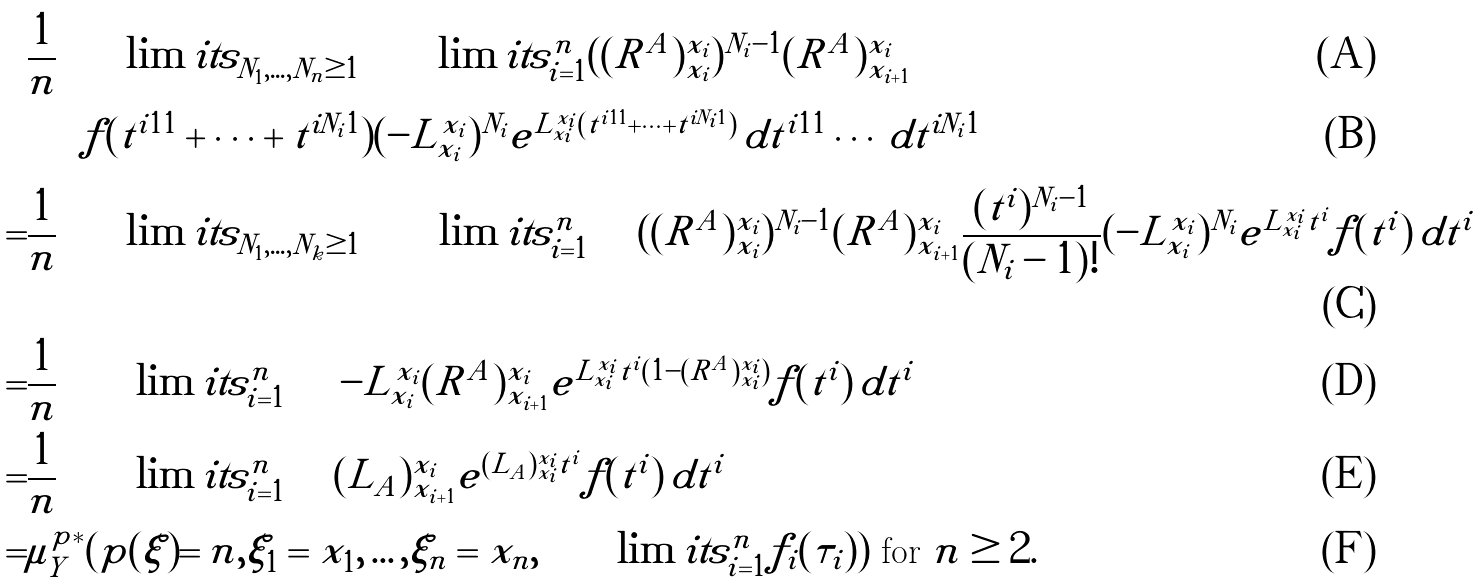<formula> <loc_0><loc_0><loc_500><loc_500>& \frac { 1 } { n } \sum \lim i t s _ { N _ { 1 } , \dots , N _ { n } \geq 1 } \prod \lim i t s _ { i = 1 } ^ { n } ( ( R ^ { A } ) ^ { x _ { i } } _ { x _ { i } } ) ^ { N _ { i } - 1 } ( R ^ { A } ) ^ { x _ { i } } _ { x _ { i + 1 } } \\ & \int f ( t ^ { i 1 1 } + \cdots + t ^ { i N _ { i } 1 } ) ( - L ^ { x _ { i } } _ { x _ { i } } ) ^ { N _ { i } } e ^ { L ^ { x _ { i } } _ { x _ { i } } ( t ^ { i 1 1 } + \cdots + t ^ { i N _ { i } 1 } ) } \, d t ^ { i 1 1 } \cdots \, d t ^ { i N _ { i } 1 } \\ = & \frac { 1 } { n } \sum \lim i t s _ { N _ { 1 } , \dots , N _ { k } \geq 1 } \prod \lim i t s _ { i = 1 } ^ { n } \int ( ( R ^ { A } ) ^ { x _ { i } } _ { x _ { i } } ) ^ { N _ { i } - 1 } ( R ^ { A } ) ^ { x _ { i } } _ { x _ { i + 1 } } \frac { ( t ^ { i } ) ^ { N _ { i } - 1 } } { ( N _ { i } - 1 ) ! } ( - L ^ { x _ { i } } _ { x _ { i } } ) ^ { N _ { i } } e ^ { L ^ { x _ { i } } _ { x _ { i } } t ^ { i } } f ( t ^ { i } ) \, d t ^ { i } \\ = & \frac { 1 } { n } \prod \lim i t s _ { i = 1 } ^ { n } \int - L ^ { x _ { i } } _ { x _ { i } } ( R ^ { A } ) ^ { x _ { i } } _ { x _ { i + 1 } } e ^ { L ^ { x _ { i } } _ { x _ { i } } t ^ { i } ( 1 - ( R ^ { A } ) ^ { x _ { i } } _ { x _ { i } } ) } f ( t ^ { i } ) \, d t ^ { i } \\ = & \frac { 1 } { n } \prod \lim i t s _ { i = 1 } ^ { n } \int ( L _ { A } ) ^ { x _ { i } } _ { x _ { i + 1 } } e ^ { ( L _ { A } ) ^ { x _ { i } } _ { x _ { i } } t ^ { i } } f ( t ^ { i } ) \, d t ^ { i } \\ = & \mu _ { Y } ^ { p * } ( p ( \xi ) = n , \xi _ { 1 } = x _ { 1 } , \dots , \xi _ { n } = x _ { n } , \prod \lim i t s _ { i = 1 } ^ { n } f _ { i } ( \tau _ { i } ) ) \text { for } n \geq 2 .</formula> 